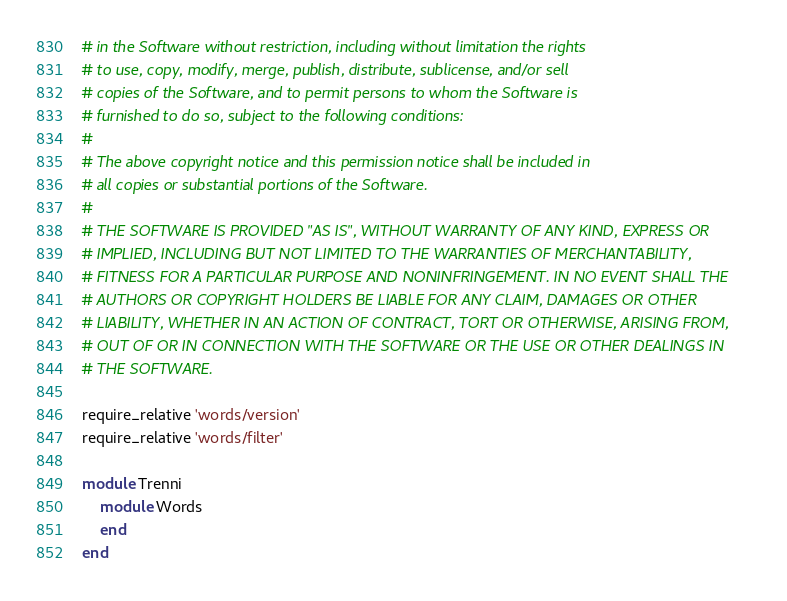Convert code to text. <code><loc_0><loc_0><loc_500><loc_500><_Ruby_># in the Software without restriction, including without limitation the rights
# to use, copy, modify, merge, publish, distribute, sublicense, and/or sell
# copies of the Software, and to permit persons to whom the Software is
# furnished to do so, subject to the following conditions:
# 
# The above copyright notice and this permission notice shall be included in
# all copies or substantial portions of the Software.
# 
# THE SOFTWARE IS PROVIDED "AS IS", WITHOUT WARRANTY OF ANY KIND, EXPRESS OR
# IMPLIED, INCLUDING BUT NOT LIMITED TO THE WARRANTIES OF MERCHANTABILITY,
# FITNESS FOR A PARTICULAR PURPOSE AND NONINFRINGEMENT. IN NO EVENT SHALL THE
# AUTHORS OR COPYRIGHT HOLDERS BE LIABLE FOR ANY CLAIM, DAMAGES OR OTHER
# LIABILITY, WHETHER IN AN ACTION OF CONTRACT, TORT OR OTHERWISE, ARISING FROM,
# OUT OF OR IN CONNECTION WITH THE SOFTWARE OR THE USE OR OTHER DEALINGS IN
# THE SOFTWARE.

require_relative 'words/version'
require_relative 'words/filter'

module Trenni
	module Words
	end
end
</code> 